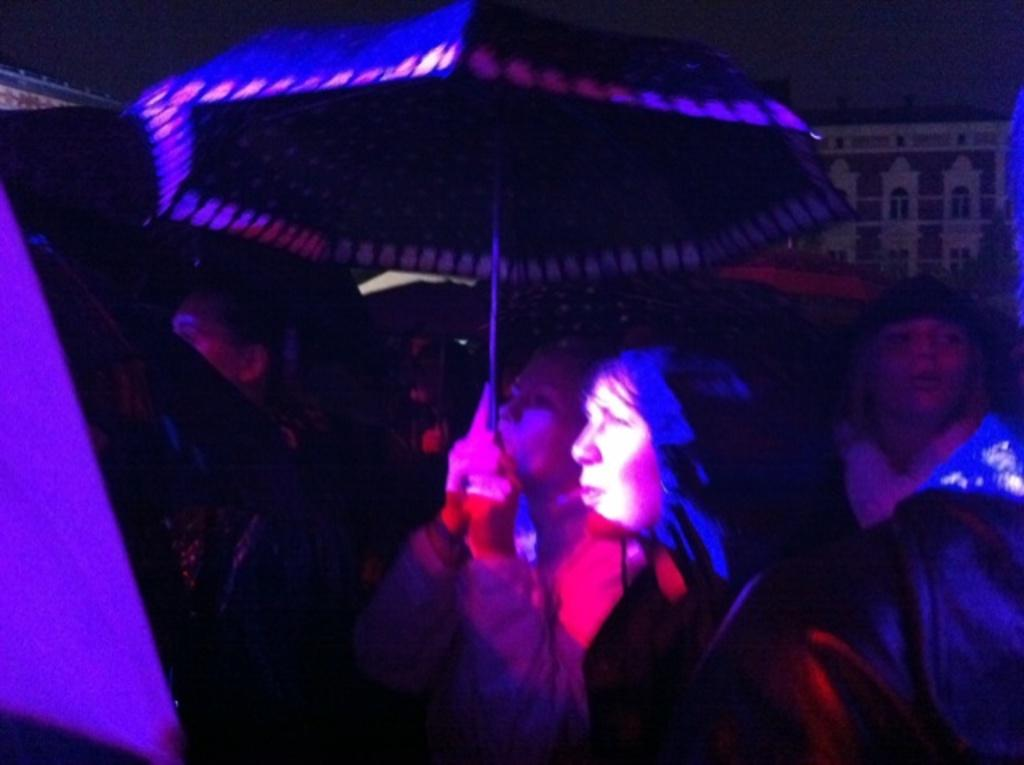How many people are in the image? There is a group of persons standing in the image. What is the woman holding in the image? The woman is holding an umbrella in the image. What can be seen in the background of the image? There is a building in the background of the image. How would you describe the lighting in the image? The image appears to be dark. What type of root can be seen growing on the woman's lip in the image? There is no root or any growth on the woman's lip in the image. What type of laborer is present in the image? There is no laborer present in the image; it features a group of persons standing together. 